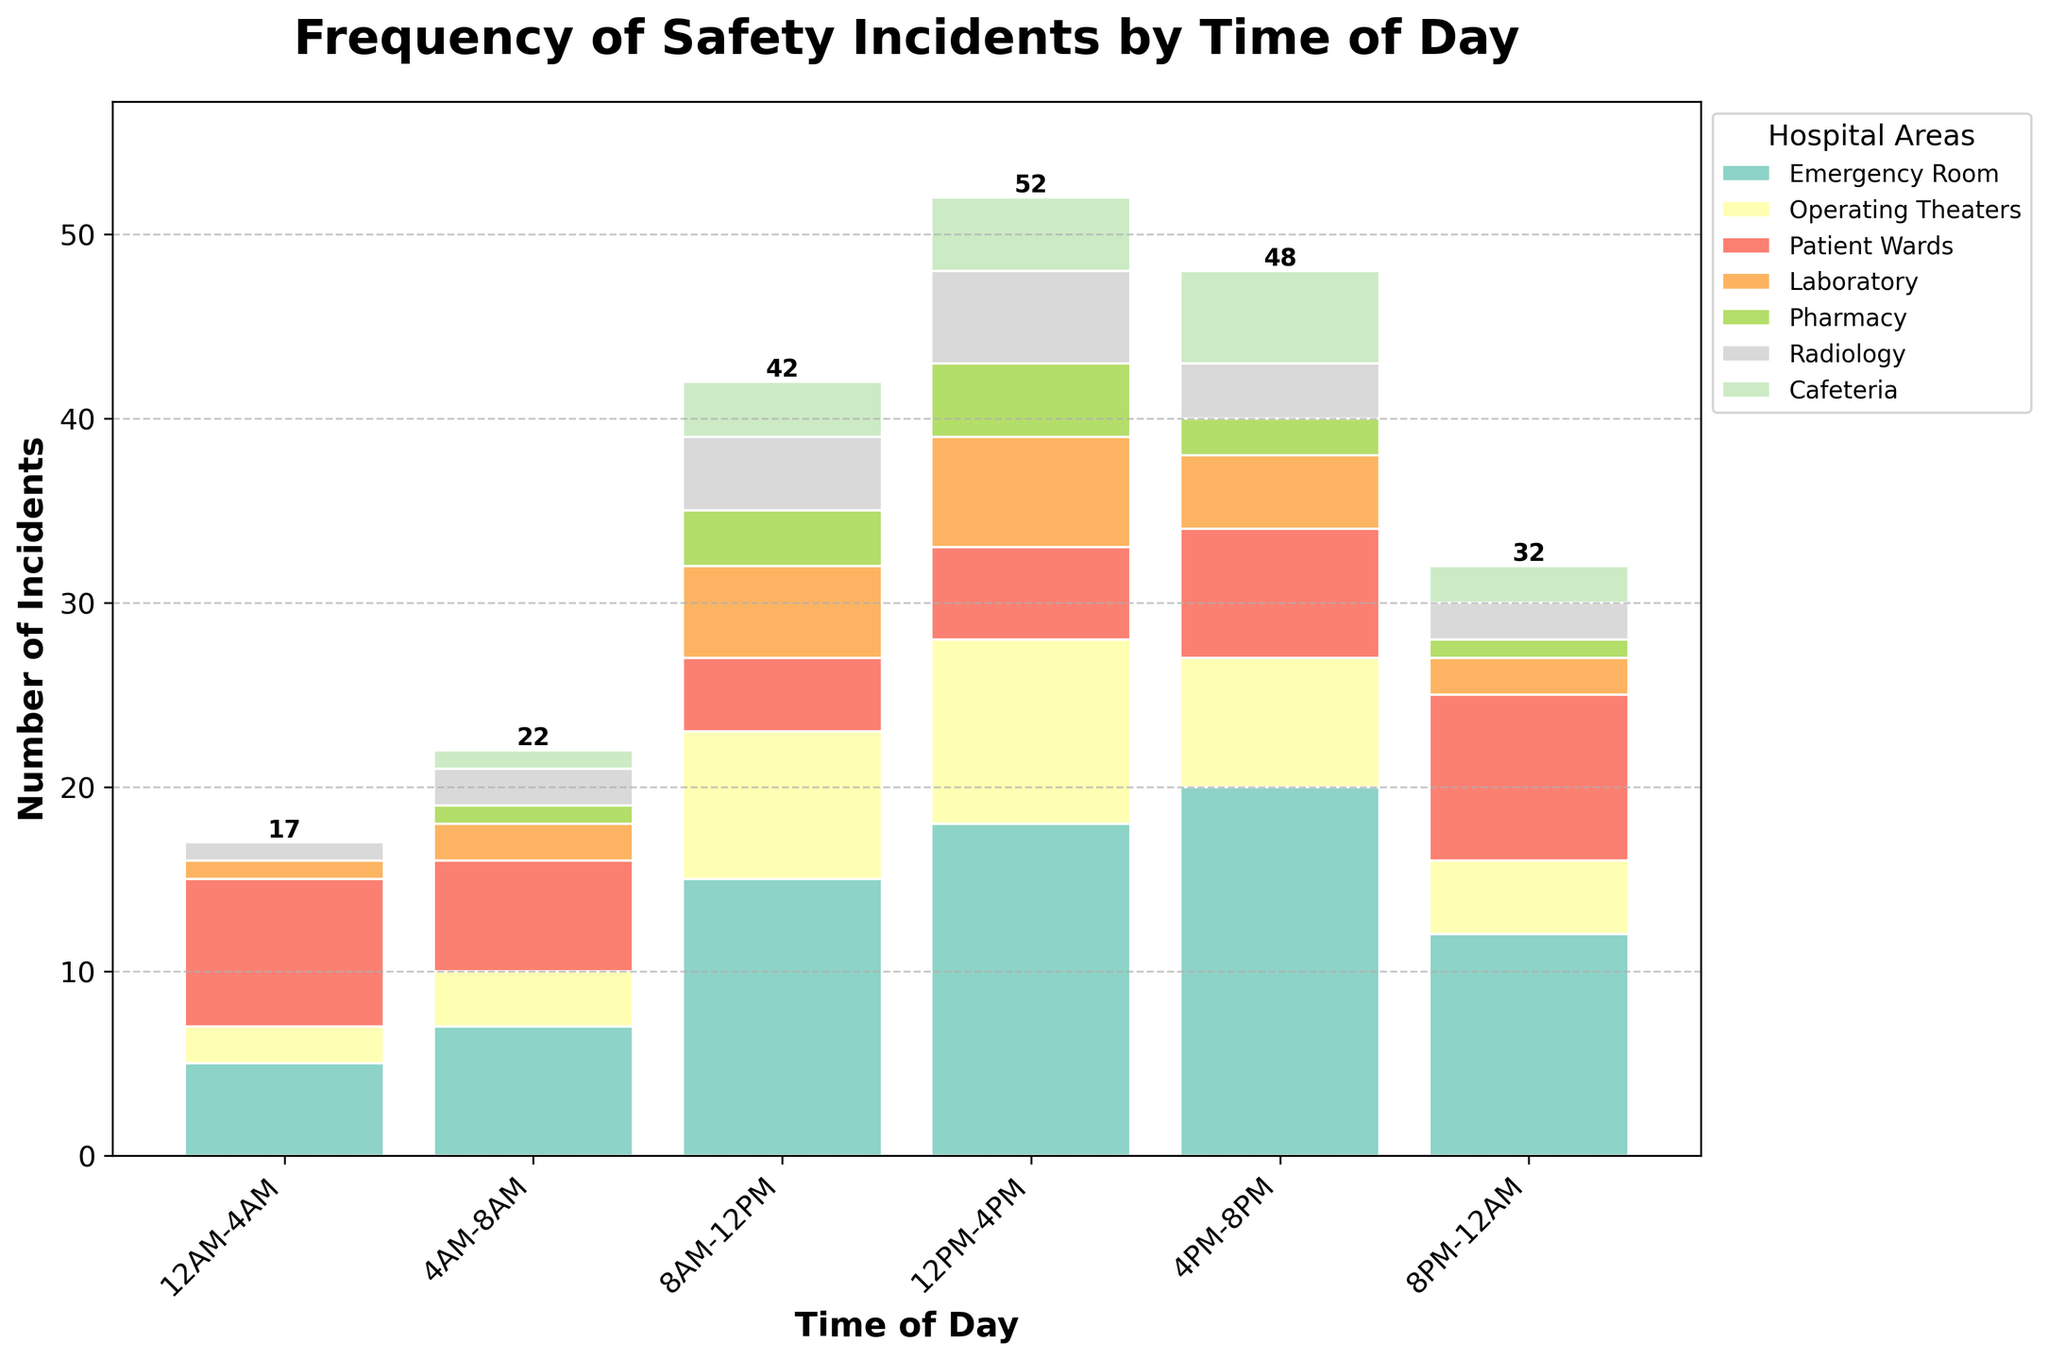Which hospital area has the highest number of safety incidents in the time period 4PM-8PM? The tallest bar segment in the 4PM-8PM time slot represents the data for the Emergency Room which stretches up to 20 incidents. Hence, the Emergency Room has the highest number of safety incidents.
Answer: Emergency Room During which time period does the Laboratory have the highest number of safety incidents? By checking the height of the bars corresponding to the Laboratory across different time slots, we observe that the highest number of incidents for the Laboratory is during 12PM-4PM, where it reaches up to 6 incidents.
Answer: 12PM-4PM What is the total number of safety incidents observed in the Pharmacy throughout the day? Summing the values for the Pharmacy across all time slots: 0 (12AM-4AM) + 1 (4AM-8AM) + 3 (8AM-12PM) + 4 (12PM-4PM) + 2 (4PM-8PM) + 1 (8PM-12AM) gives a total of 11.
Answer: 11 Which time period has the least number of total safety incidents across all areas? By examining the summed heights of the bars across each time slot, the time period with the least number of incidents is 12AM-4AM. Adding the numbers: 5 + 2 + 8 + 1 + 0 + 1 + 0, we get 17 incidents.
Answer: 12AM-4AM Out of Patient Wards and Radiology, which area has more incidents during 8AM-12PM? Comparing the bar heights for Patient Wards and Radiology during 8AM-12PM, Patient Wards has 4 incidents while Radiology has 4 incidents as well. Therefore, both areas have the same number of incidents.
Answer: Both What's the average number of safety incidents in the Operating Theaters for the entire day? Summing the values for Operating Theaters across all time slots: 2 + 3 + 8 + 10 + 7 + 4 gives a total of 34. Dividing by the number of time slots (6), the average is 34/6 ≈ 5.67 incidents.
Answer: 5.67 How many total safety incidents occur in the time slot 8PM-12AM? Summing up the numbers across all hospital areas for this time slot: 12 (Emergency Room) + 4 (Operating Theaters) + 9 (Patient Wards) + 2 (Laboratory) + 1 (Pharmacy) + 2 (Radiology) + 2 (Cafeteria) gives a total of 32 incidents.
Answer: 32 